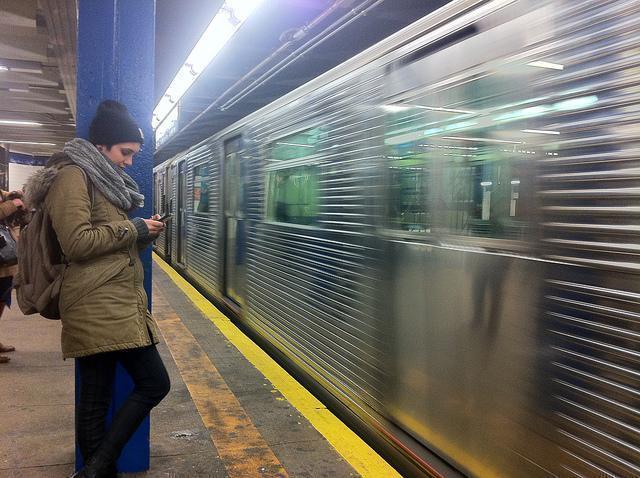The person next to the train looks like who?
Answer the question by selecting the correct answer among the 4 following choices and explain your choice with a short sentence. The answer should be formatted with the following format: `Answer: choice
Rationale: rationale.`
Options: Tracy ifeachor, james horner, ned beatty, margaret qualley. Answer: margaret qualley.
Rationale: The person wears a similar outfit the character. 